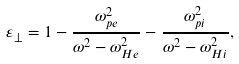Convert formula to latex. <formula><loc_0><loc_0><loc_500><loc_500>\varepsilon _ { \perp } = 1 - \frac { \omega _ { p e } ^ { 2 } } { \omega ^ { 2 } - \omega _ { H e } ^ { 2 } } - \frac { \omega _ { p i } ^ { 2 } } { \omega ^ { 2 } - \omega _ { H i } ^ { 2 } } ,</formula> 